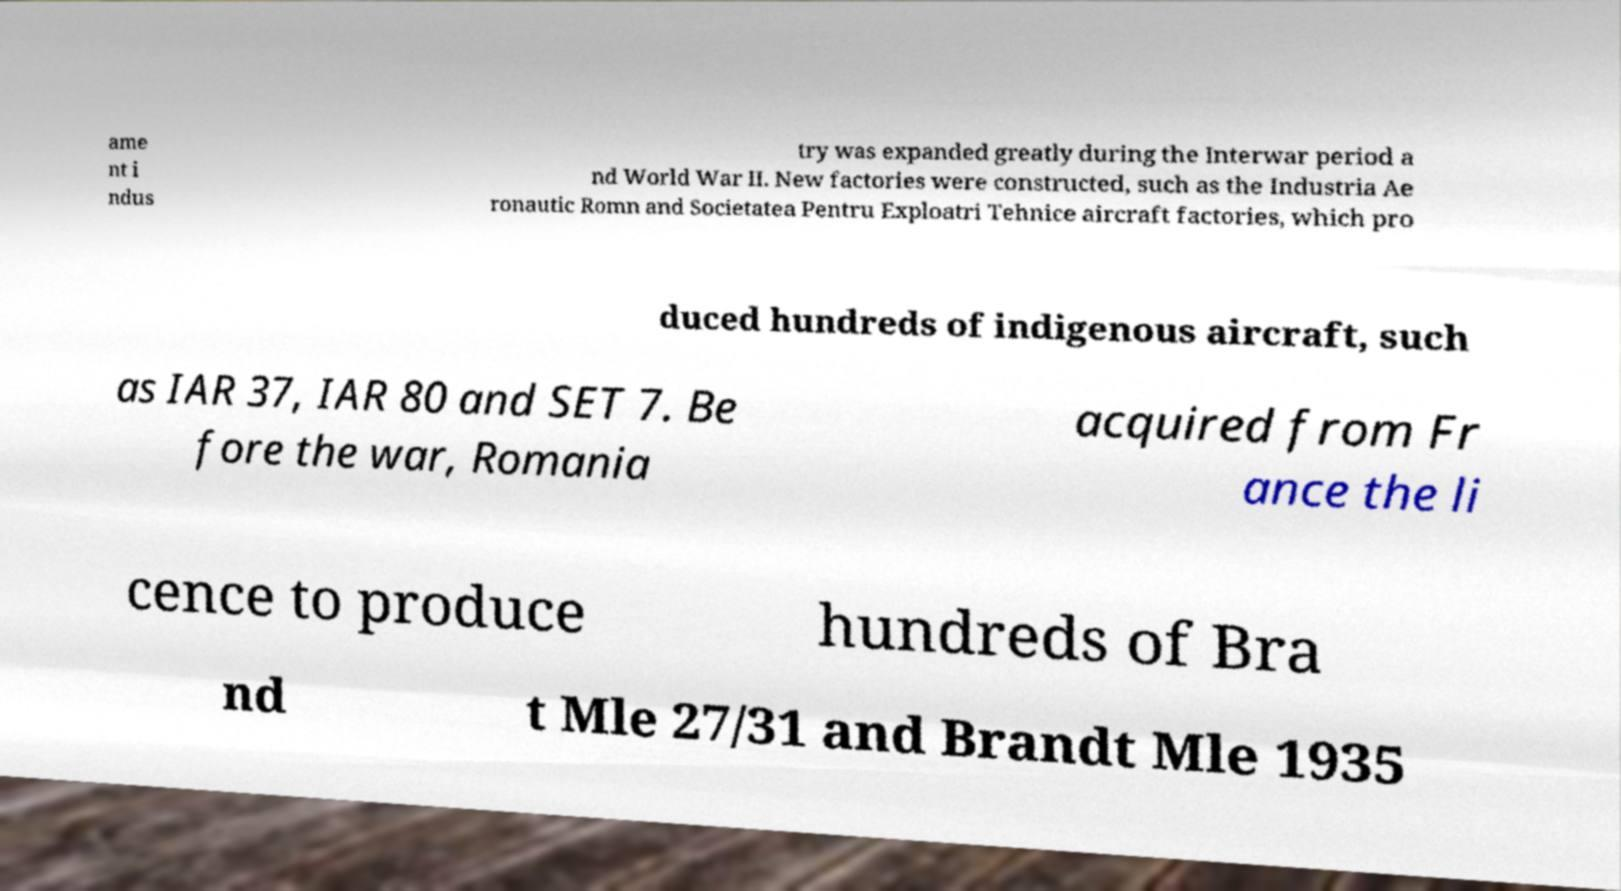Please read and relay the text visible in this image. What does it say? ame nt i ndus try was expanded greatly during the Interwar period a nd World War II. New factories were constructed, such as the Industria Ae ronautic Romn and Societatea Pentru Exploatri Tehnice aircraft factories, which pro duced hundreds of indigenous aircraft, such as IAR 37, IAR 80 and SET 7. Be fore the war, Romania acquired from Fr ance the li cence to produce hundreds of Bra nd t Mle 27/31 and Brandt Mle 1935 